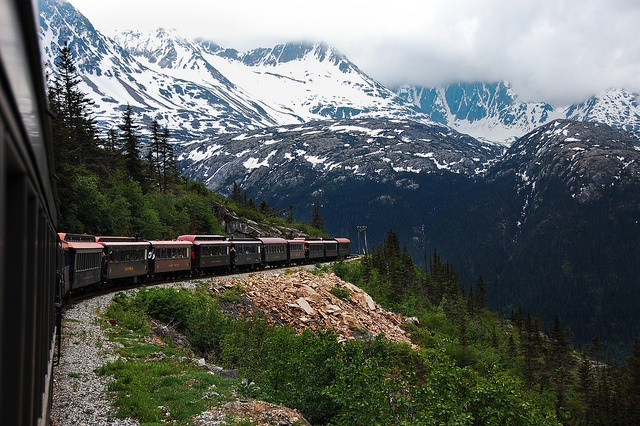Describe the objects in this image and their specific colors. I can see a train in darkgray, black, gray, and maroon tones in this image. 